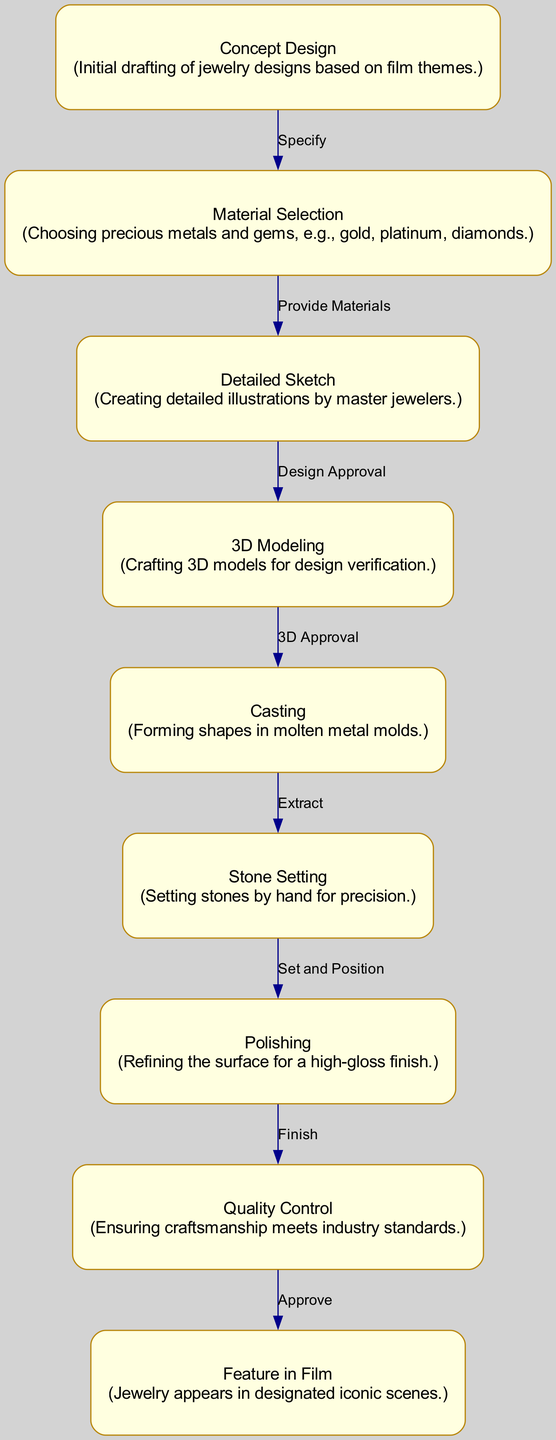What is the first process in the diagram? The diagram starts with the node "Concept Design," which is the initial step in the craftsmanship process for jewelry. Therefore, the answer is derived directly from the beginning node in the flowchart.
Answer: Concept Design How many nodes are present in the diagram? By counting the nodes provided in the data, we find a total of nine nodes that represent different stages in the craftsmanship process. Therefore, the answer is obtained by simply counting these nodes listed in the diagram.
Answer: 9 What process follows the "Stone Setting"? According to the flow of the diagram, after "Stone Setting," the next step is "Polishing," as indicated by the arrow leading from Stone Setting to Polishing. Thus, the answer is found by tracing the connection in the flowchart.
Answer: Polishing What label comes after "Casting"? Following the node "Casting," the next node is "Stone Setting," which is noted in the diagram’s connections. The answer is found by identifying the next step in the process as defined by the edges in the diagram.
Answer: Stone Setting How many edges are used to connect the nodes? The total number of edges can be counted from the 'edges' data provided, where there are eight connections specified between the nodes. The answer is determined by counting each directed connection from one process to another.
Answer: 8 Which process does "Quality Control" lead to? "Quality Control" leads to the node labeled "Feature in Film," as indicated by the directed edge from Quality Control to Feature in Film in the diagram. The answer comes from examining the endpoint of the edge connected to Quality Control.
Answer: Feature in Film What is the last step in the craftsmanship process? The final stage is highlighted by the node "Feature in Film," which represents the point where the jewelry is showcased in a film. The answer is determined by identifying the last node within the flow of the craftsmanship processes.
Answer: Feature in Film Which process occurs immediately after "Material Selection"? Right after "Material Selection," the next node is "Detailed Sketch," which follows directly in the flowchart. The answer is determined by the direct connection outlined in the process sequence in the diagram.
Answer: Detailed Sketch What is required for moving from "Sketch Detailed" to "3D Modeling"? The transition from "Sketch Detailed" to "3D Modeling" is based on "Design Approval," which is the prerequisite for moving to the next stage. Thus, the answer is derived from the edge label indicating this requirement.
Answer: Design Approval 